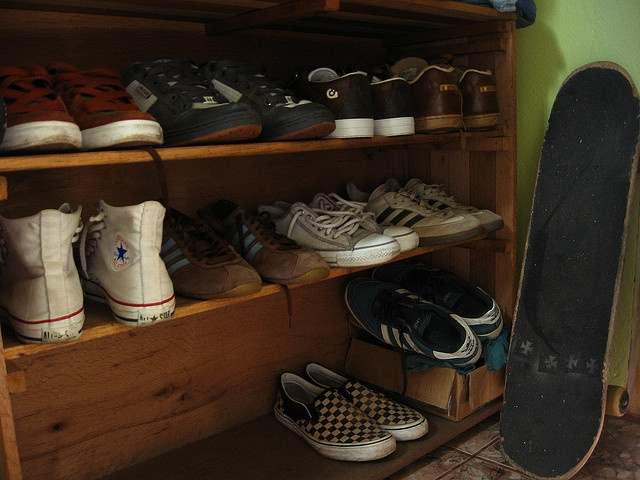Describe the objects in this image and their specific colors. I can see a skateboard in black, gray, and maroon tones in this image. 